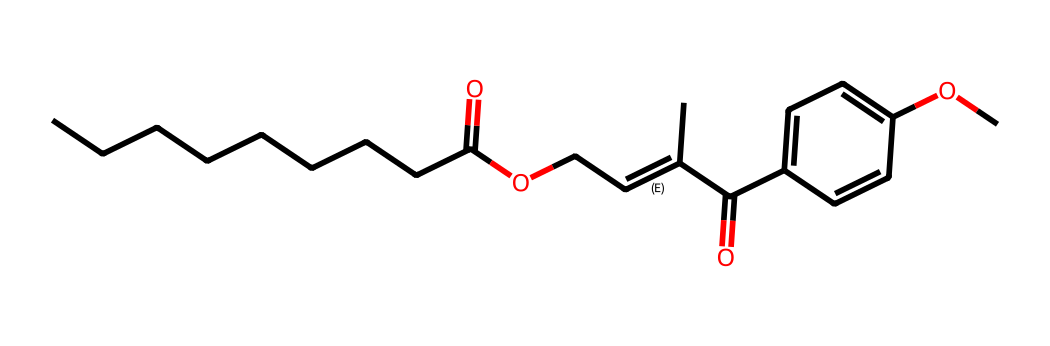What type of functional groups are present in this structure? The chemical structure shows the presence of an ester functional group (–C(=O)OC–) and two carbonyl groups (–C(=O)–). The ester is indicated by the combination of a carbonyl (C=O) attached to an oxygen (O) which is also bonded to carbon (C).
Answer: ester and carbonyl How many rings are present in this chemical? The chemical structure does not contain any rings; it consists of linear and branched aliphatic components along with a phenyl ring from the aromatic compound. Looking at the visual representation, there are no closed loops indicating ring structures.
Answer: zero What is the total number of carbon atoms in this structure? By analyzing the SMILES representation, we can count each carbon atom. There are nine carbons from the long alkyl chain, two from the carbonyl groups, and six from the aromatic ring (c1ccc(OC)cc1), totaling seventeen carbon atoms.
Answer: seventeen Is this compound likely to be hydrophilic or hydrophobic? The presence of long carbon chains and the carbonyl groups suggest a hydrophobic nature primarily due to the non-polar character of the long aliphatic chain. Also, the overall composition leans towards greater hydrophobicity, as polar groups are minimal, leading to lower solubility in water.
Answer: hydrophobic What is the role of this compound in sunscreen formulations? The presence of specific functional groups like carbonyls and aromatic rings indicates that this compound is likely used as an ultraviolet (UV) filter to absorb UV light, helping to protect the skin from damage caused by radiation.
Answer: UV filter 